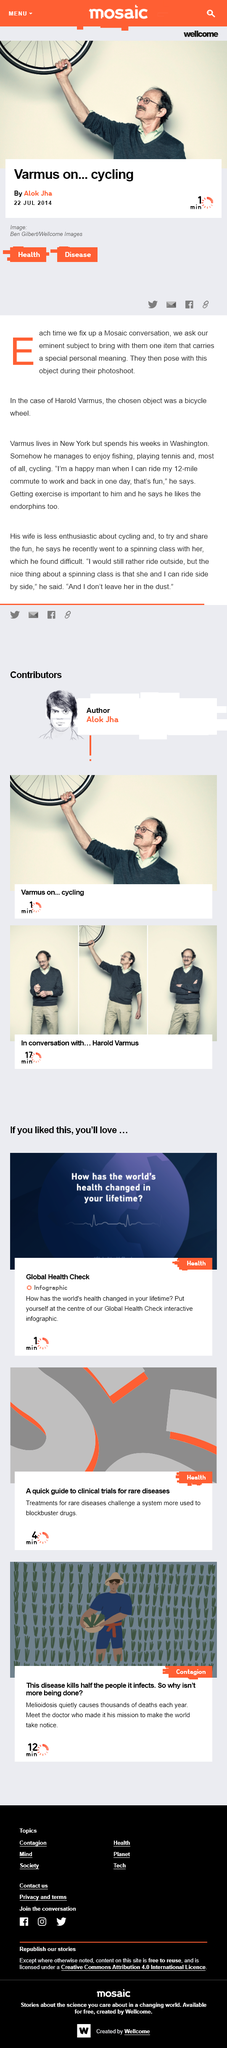Highlight a few significant elements in this photo. Varmus lives in New York. Varmus enjoys fishing, playing tennis, and cycling, which are his favorite activities. Varmus's wife enjoys taking spinning classes. 